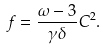Convert formula to latex. <formula><loc_0><loc_0><loc_500><loc_500>f = \frac { \omega - 3 } { \gamma \delta } C ^ { 2 } .</formula> 